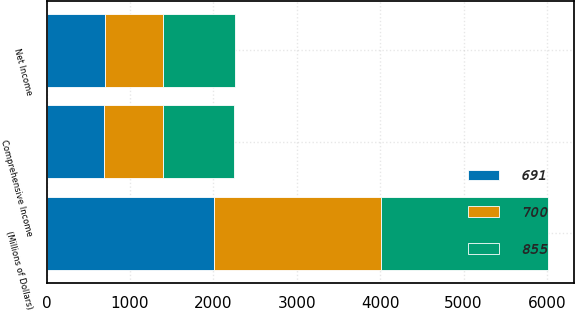Convert chart. <chart><loc_0><loc_0><loc_500><loc_500><stacked_bar_chart><ecel><fcel>(Millions of Dollars)<fcel>Net Income<fcel>Comprehensive Income<nl><fcel>855<fcel>2007<fcel>855<fcel>855<nl><fcel>691<fcel>2006<fcel>697<fcel>691<nl><fcel>700<fcel>2005<fcel>705<fcel>700<nl></chart> 